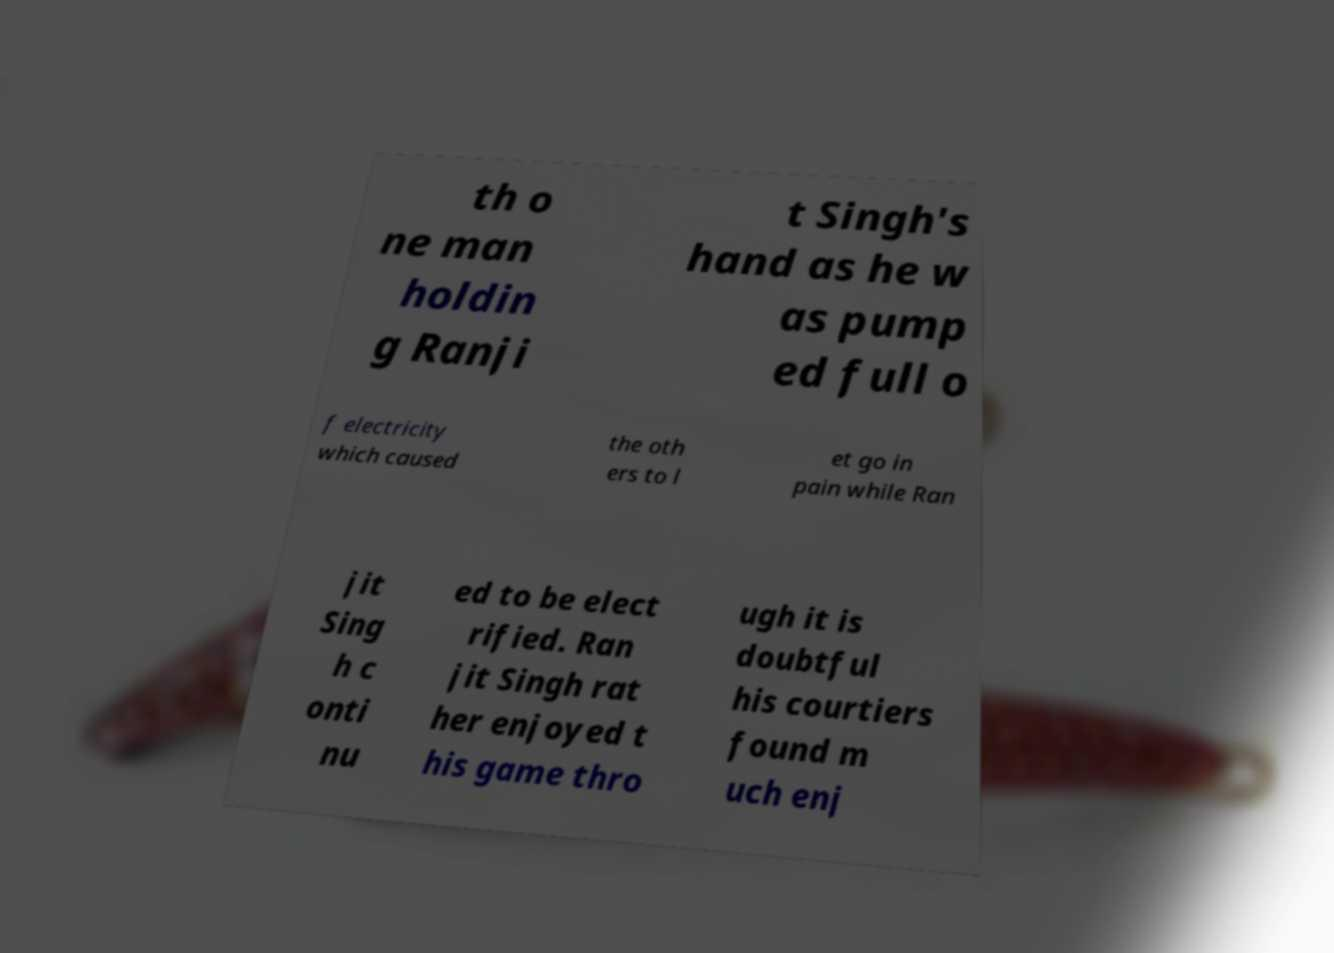Please read and relay the text visible in this image. What does it say? th o ne man holdin g Ranji t Singh's hand as he w as pump ed full o f electricity which caused the oth ers to l et go in pain while Ran jit Sing h c onti nu ed to be elect rified. Ran jit Singh rat her enjoyed t his game thro ugh it is doubtful his courtiers found m uch enj 